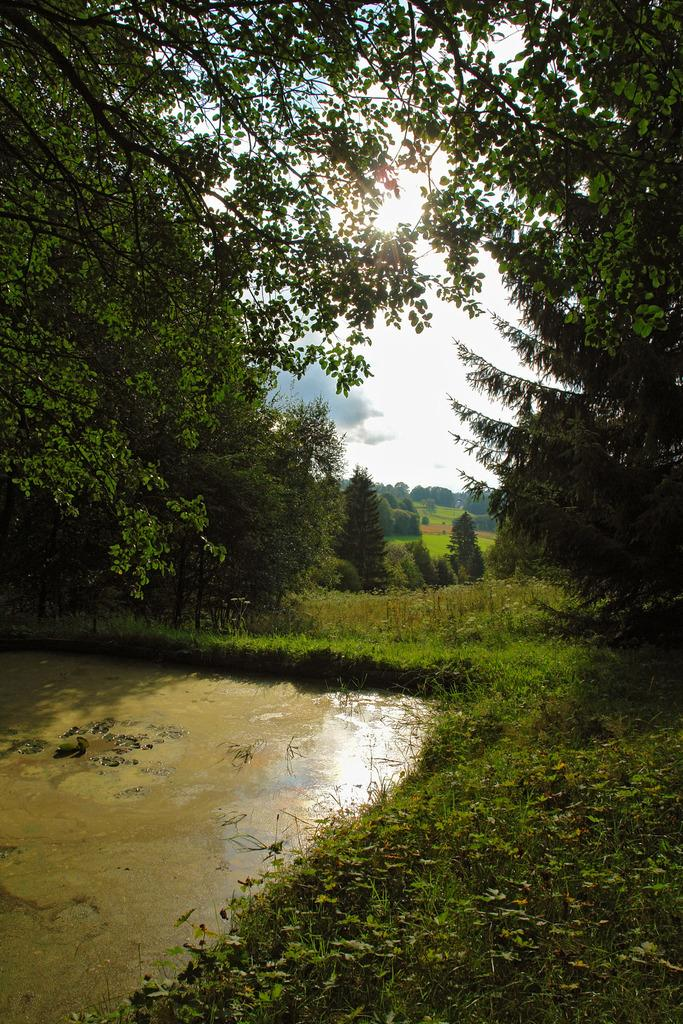What is the color of the water in the image? The water in the image is brown. What can be seen in the background of the image? There are trees and plants in the background of the image. What colors are visible in the sky in the image? The sky in the image has a combination of white and blue colors. How much income does the horse in the image earn? There is no horse present in the image, so the question of income is not applicable. 